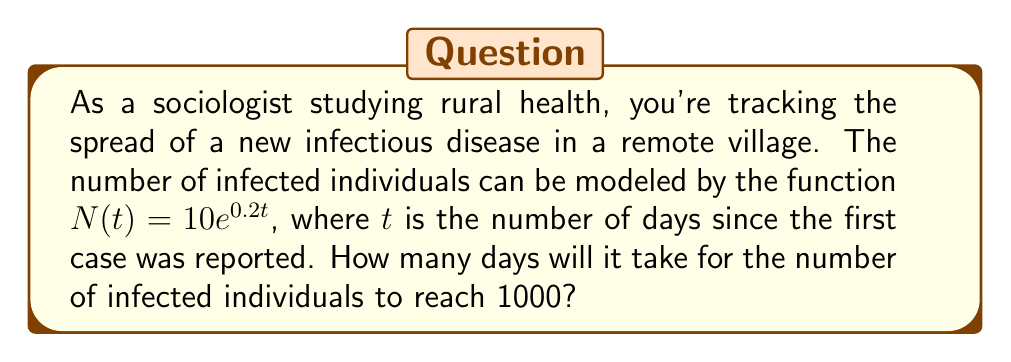Help me with this question. Let's approach this step-by-step:

1) We're given the function $N(t) = 10e^{0.2t}$, where:
   - $N(t)$ is the number of infected individuals
   - $t$ is the number of days since the first case
   - We need to find $t$ when $N(t) = 1000$

2) Set up the equation:
   $1000 = 10e^{0.2t}$

3) Divide both sides by 10:
   $100 = e^{0.2t}$

4) Take the natural logarithm of both sides:
   $\ln(100) = \ln(e^{0.2t})$

5) Simplify the right side using the property of logarithms:
   $\ln(100) = 0.2t$

6) Calculate $\ln(100)$:
   $4.60517 = 0.2t$

7) Divide both sides by 0.2:
   $\frac{4.60517}{0.2} = t$

8) Calculate the final result:
   $t \approx 23.02585$

9) Since we're dealing with days, we need to round up to the nearest whole number:
   $t = 24$ days
Answer: 24 days 